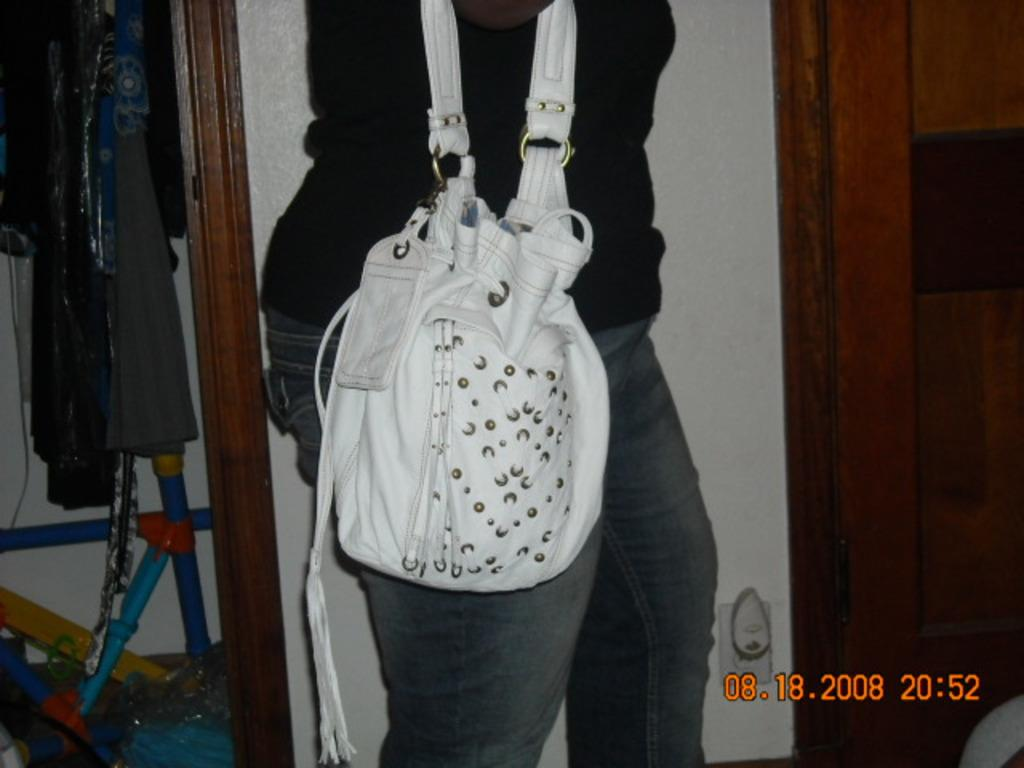What is the main subject of the image? There is a person in the image. What is the person holding in the image? The person is holding a handbag. What can be seen in the background of the image? There is a wall in the background of the image. Where is the entrance located in the image? There is an entrance on the left side of the image. Reasoning: Let's think step by step by step in order to produce the conversation. We start by identifying the main subject of the image, which is the person. Then, we describe what the person is holding, which is a handbag. Next, we mention the background of the image, which includes a wall. Finally, we point out the entrance on the left side of the image. Each question is designed to elicit a specific detail about the image that is known from the provided facts. Absurd Question/Answer: What type of potato is being grown in the image? There is no potato present in the image. In which direction is the person facing in the image? The provided facts do not indicate the direction the person is facing. What type of potato is being grown in the image? There is no potato present in the image. In which direction is the person facing in the image? The provided facts do not indicate the direction the person is facing. 